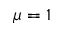Convert formula to latex. <formula><loc_0><loc_0><loc_500><loc_500>\mu = 1</formula> 